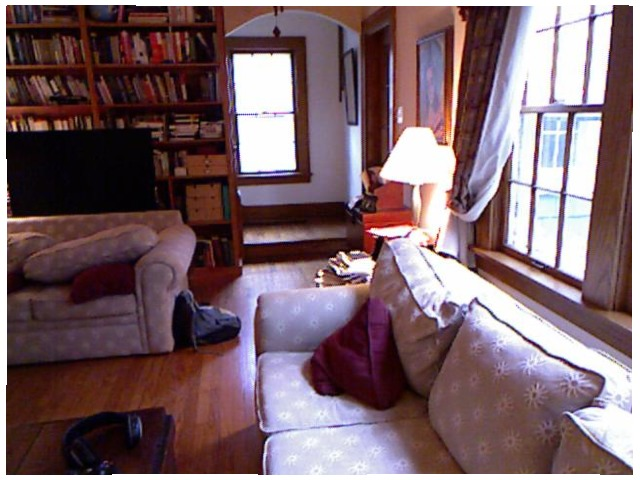<image>
Is there a red pillow under the pink pillow? Yes. The red pillow is positioned underneath the pink pillow, with the pink pillow above it in the vertical space. Is the tv under the headphones? No. The tv is not positioned under the headphones. The vertical relationship between these objects is different. Is there a backpack on the sofa? No. The backpack is not positioned on the sofa. They may be near each other, but the backpack is not supported by or resting on top of the sofa. Where is the light in relation to the sofa? Is it behind the sofa? Yes. From this viewpoint, the light is positioned behind the sofa, with the sofa partially or fully occluding the light. Where is the window in relation to the sofa? Is it next to the sofa? Yes. The window is positioned adjacent to the sofa, located nearby in the same general area. 